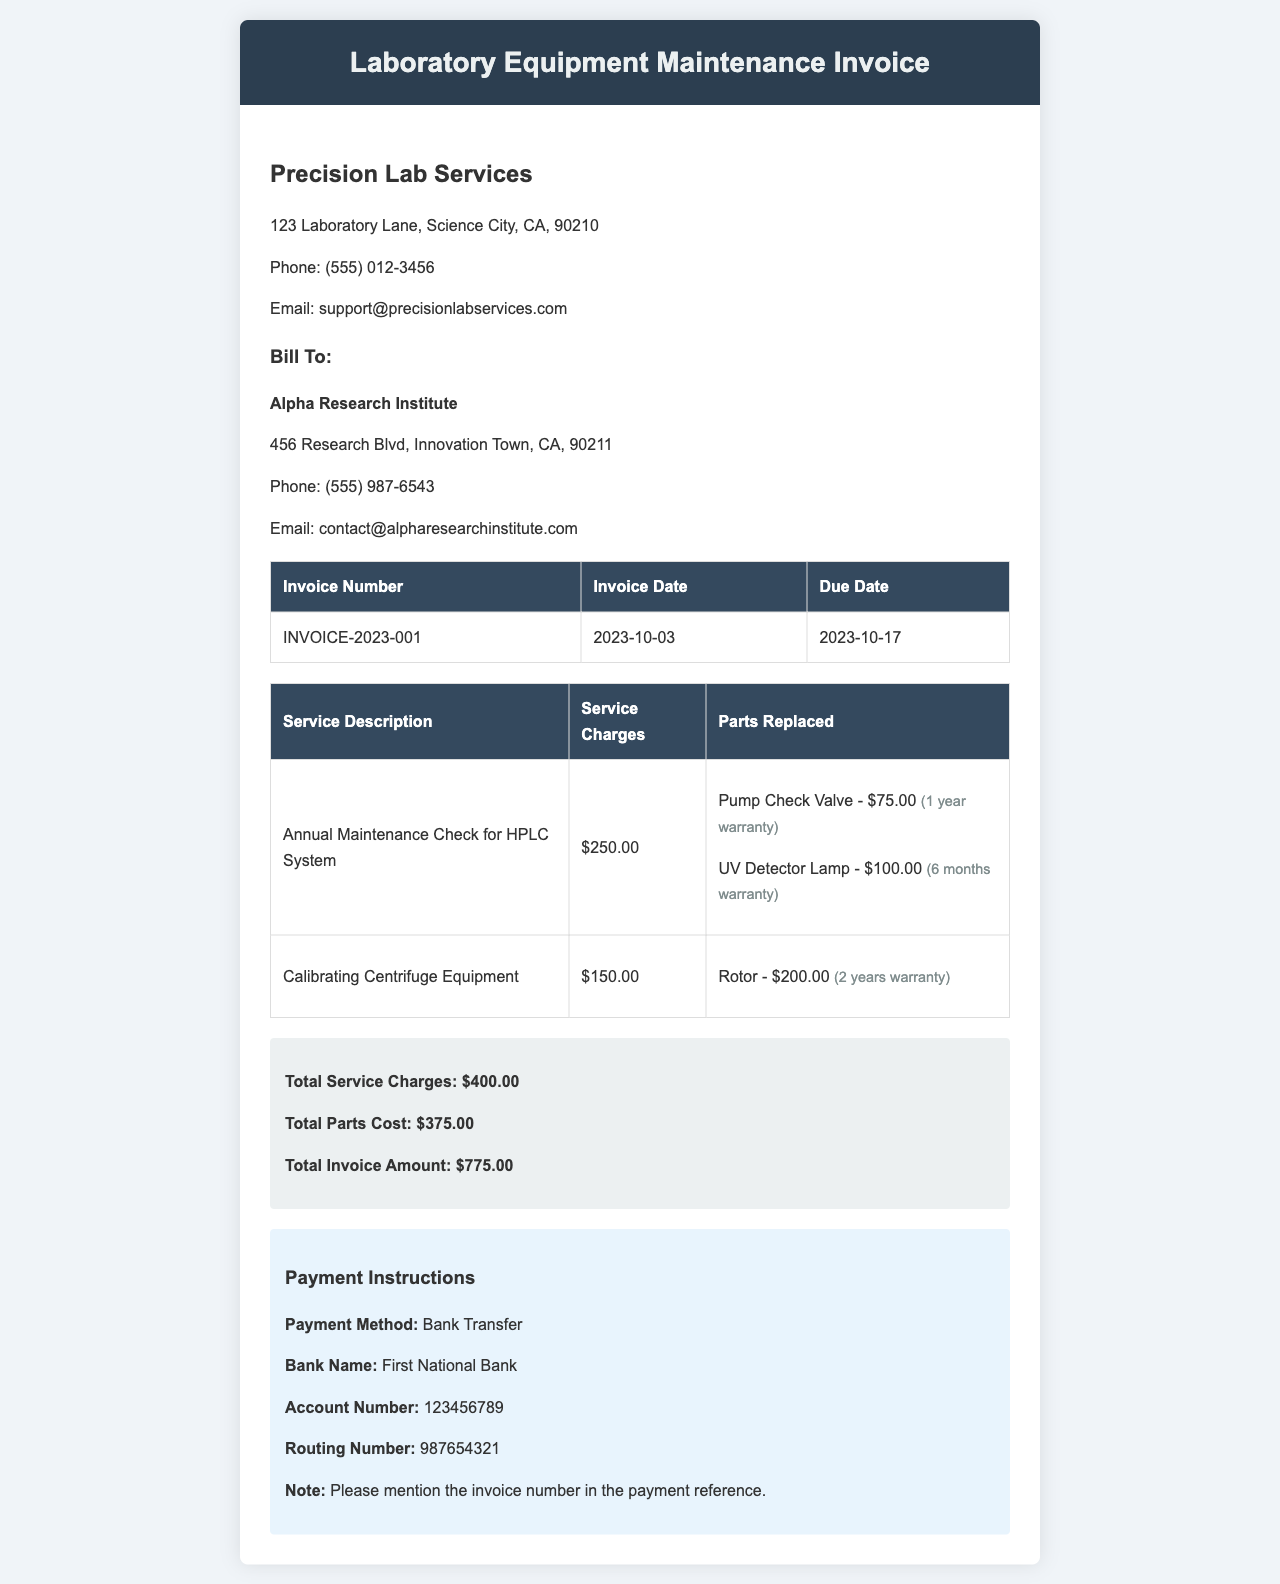What is the invoice number? The invoice number is specified in the document, found in the invoice table.
Answer: INVOICE-2023-001 When is the invoice due? The due date is mentioned in the invoice table.
Answer: 2023-10-17 Who is the billing client? The document specifies the billing client in the client details section.
Answer: Alpha Research Institute What is the total invoice amount? The total invoice amount is summarized at the end of the invoice.
Answer: $775.00 How much was charged for the annual maintenance check? The service charges are listed next to the service description in the invoice table.
Answer: $250.00 What is the total service charges? The total service charges are provided in the invoice summary section.
Answer: $400.00 What is the warranty period for the pump check valve? The warranty details for the parts replaced are mentioned in the service charges section.
Answer: 1 year What parts were replaced during the maintenance? The parts replaced are listed in the invoice under each service charge.
Answer: Pump Check Valve, UV Detector Lamp, Rotor What payment method is specified in the document? The payment method is mentioned in the payment instructions section.
Answer: Bank Transfer 